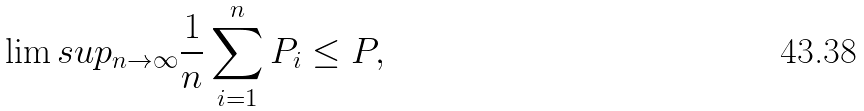<formula> <loc_0><loc_0><loc_500><loc_500>\lim s u p _ { n \to \infty } \frac { 1 } { n } \sum _ { i = 1 } ^ { n } P _ { i } \leq P ,</formula> 